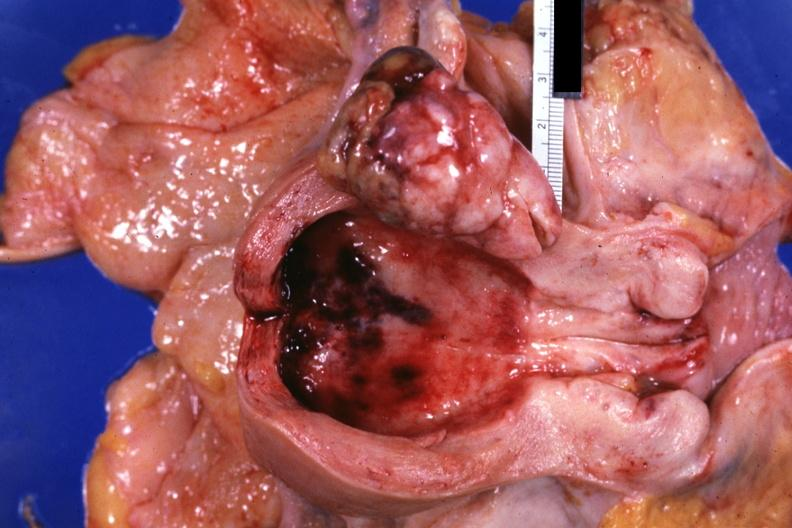what demonstrated?
Answer the question using a single word or phrase. Uterus polypoid tumor 